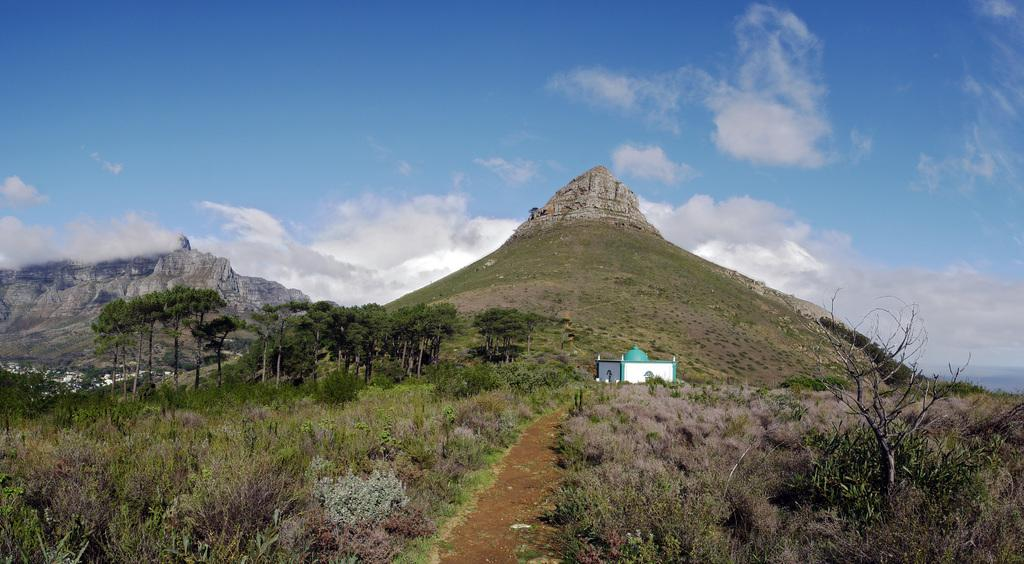What type of terrain is visible in the image? There are hills in the image. What can be seen on the ground in the image? The ground is visible in the image, and there is grass on it. What other types of vegetation can be seen in the image? There are plants and trees in the image. Is there any man-made structure visible in the image? Yes, there is a house in the image. What is visible in the sky in the image? The sky is visible in the image, and there are clouds present. How many dimes are scattered on the grass in the image? There are no dimes present in the image; it features hills, grass, plants, trees, a house, sky, and clouds. How many passengers are visible in the house in the image? There are no passengers visible in the image, as it does not depict any people or vehicles. 